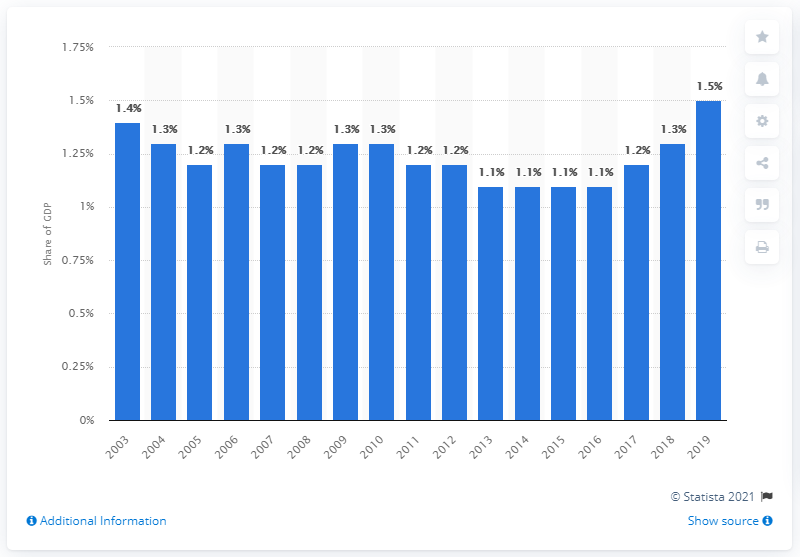Point out several critical features in this image. According to estimates, military expenditure is expected to make up approximately 1.5% of New Zealand's gross domestic product in 2019. 